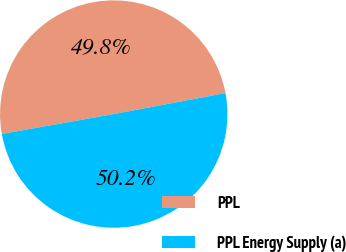Convert chart. <chart><loc_0><loc_0><loc_500><loc_500><pie_chart><fcel>PPL<fcel>PPL Energy Supply (a)<nl><fcel>49.85%<fcel>50.15%<nl></chart> 